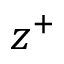Convert formula to latex. <formula><loc_0><loc_0><loc_500><loc_500>z ^ { + }</formula> 